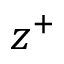Convert formula to latex. <formula><loc_0><loc_0><loc_500><loc_500>z ^ { + }</formula> 